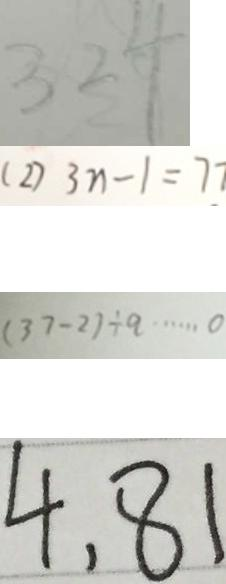Convert formula to latex. <formula><loc_0><loc_0><loc_500><loc_500>3 2 4 
 ( 2 ) 3 n - 1 = 7 7 
 ( 3 7 - 2 ) \div q \cdots 0 
 4 , 8 1</formula> 